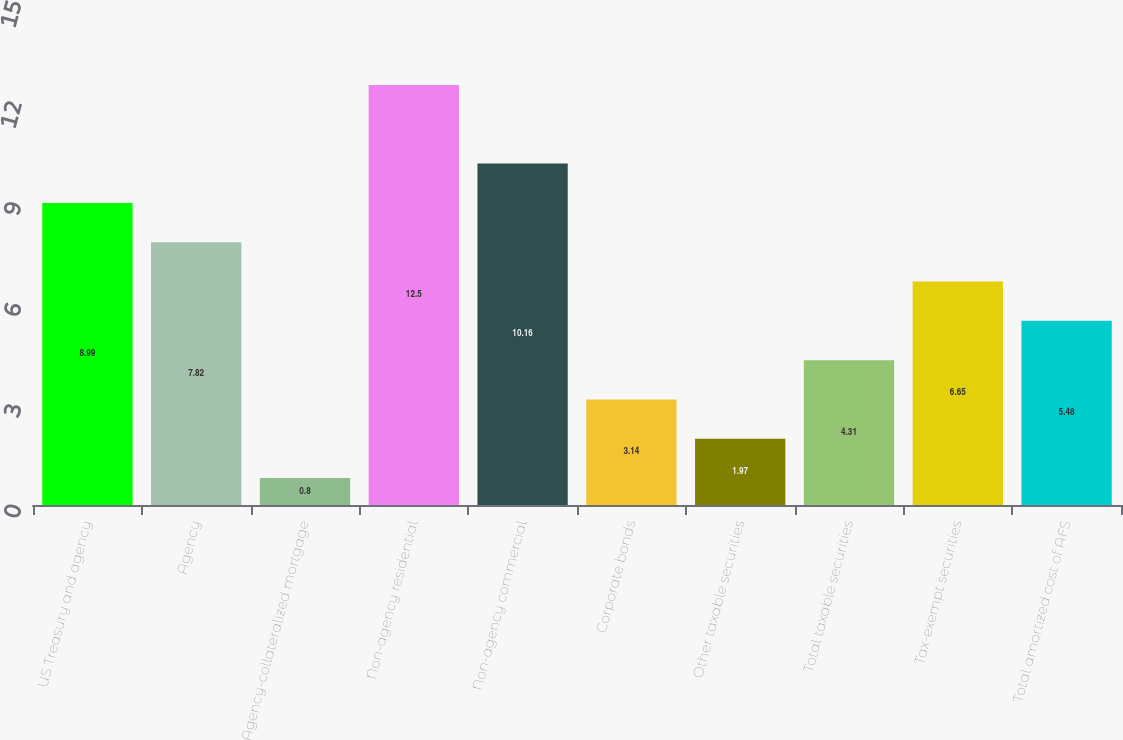<chart> <loc_0><loc_0><loc_500><loc_500><bar_chart><fcel>US Treasury and agency<fcel>Agency<fcel>Agency-collateralized mortgage<fcel>Non-agency residential<fcel>Non-agency commercial<fcel>Corporate bonds<fcel>Other taxable securities<fcel>Total taxable securities<fcel>Tax-exempt securities<fcel>Total amortized cost of AFS<nl><fcel>8.99<fcel>7.82<fcel>0.8<fcel>12.5<fcel>10.16<fcel>3.14<fcel>1.97<fcel>4.31<fcel>6.65<fcel>5.48<nl></chart> 